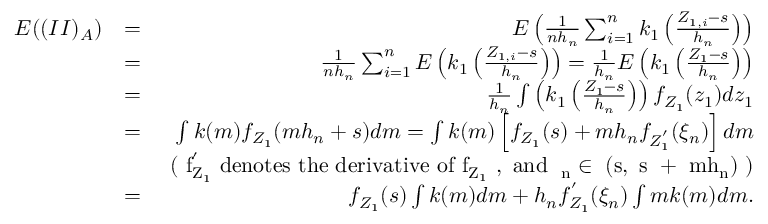<formula> <loc_0><loc_0><loc_500><loc_500>\begin{array} { r l r } { E ( ( I I ) _ { A } ) } & { = } & { E \left ( \frac { 1 } { n h _ { n } } \sum _ { i = 1 } ^ { n } k _ { 1 } \left ( \frac { Z _ { 1 , i } - s } { h _ { n } } \right ) \right ) } \\ & { = } & { \frac { 1 } { n h _ { n } } \sum _ { i = 1 } ^ { n } E \left ( k _ { 1 } \left ( \frac { Z _ { 1 , i } - s } { h _ { n } } \right ) \right ) = \frac { 1 } { h _ { n } } E \left ( k _ { 1 } \left ( \frac { Z _ { 1 } - s } { h _ { n } } \right ) \right ) } \\ & { = } & { \frac { 1 } { h _ { n } } \int \left ( k _ { 1 } \left ( \frac { Z _ { 1 } - s } { h _ { n } } \right ) \right ) f _ { Z _ { 1 } } ( z _ { 1 } ) d z _ { 1 } } \\ & { = } & { \int k ( m ) f _ { Z _ { 1 } } ( m h _ { n } + s ) d m = \int k ( m ) \left [ f _ { Z _ { 1 } } ( s ) + m h _ { n } f _ { Z _ { 1 } ^ { ^ { \prime } } } ( \xi _ { n } ) \right ] d m } \\ & { ( f _ { Z _ { 1 } } ^ { ^ { \prime } } d e n o t e s t h e d e r i v a t i v e o f f _ { Z _ { 1 } } , a n d \xi _ { n } \in ( s , s + m h _ { n } ) ) } \\ & { = } & { f _ { Z _ { 1 } } ( s ) \int k ( m ) d m + h _ { n } f _ { Z _ { 1 } } ^ { ^ { \prime } } ( \xi _ { n } ) \int m k ( m ) d m . } \end{array}</formula> 